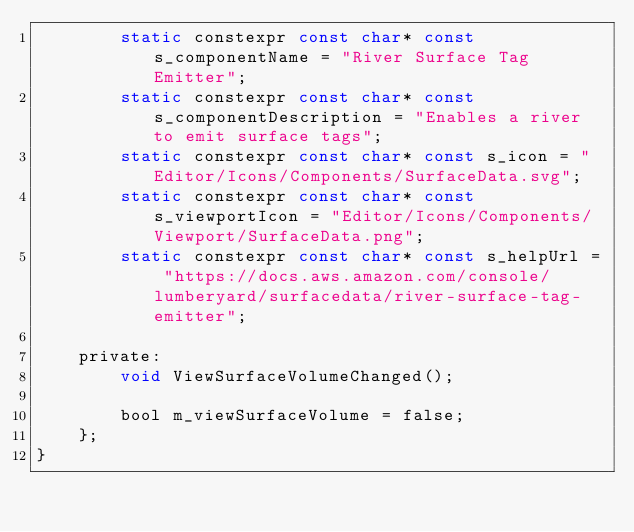Convert code to text. <code><loc_0><loc_0><loc_500><loc_500><_C_>        static constexpr const char* const s_componentName = "River Surface Tag Emitter";
        static constexpr const char* const s_componentDescription = "Enables a river to emit surface tags";
        static constexpr const char* const s_icon = "Editor/Icons/Components/SurfaceData.svg";
        static constexpr const char* const s_viewportIcon = "Editor/Icons/Components/Viewport/SurfaceData.png";
        static constexpr const char* const s_helpUrl = "https://docs.aws.amazon.com/console/lumberyard/surfacedata/river-surface-tag-emitter";

    private:
        void ViewSurfaceVolumeChanged();

        bool m_viewSurfaceVolume = false;
    };
}</code> 